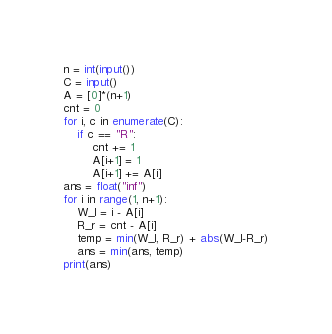<code> <loc_0><loc_0><loc_500><loc_500><_Python_>n = int(input())
C = input()
A = [0]*(n+1)
cnt = 0
for i, c in enumerate(C):
    if c == "R":
        cnt += 1
        A[i+1] = 1
        A[i+1] += A[i]
ans = float("inf")
for i in range(1, n+1):
    W_l = i - A[i]
    R_r = cnt - A[i]
    temp = min(W_l, R_r) + abs(W_l-R_r)
    ans = min(ans, temp)
print(ans)</code> 